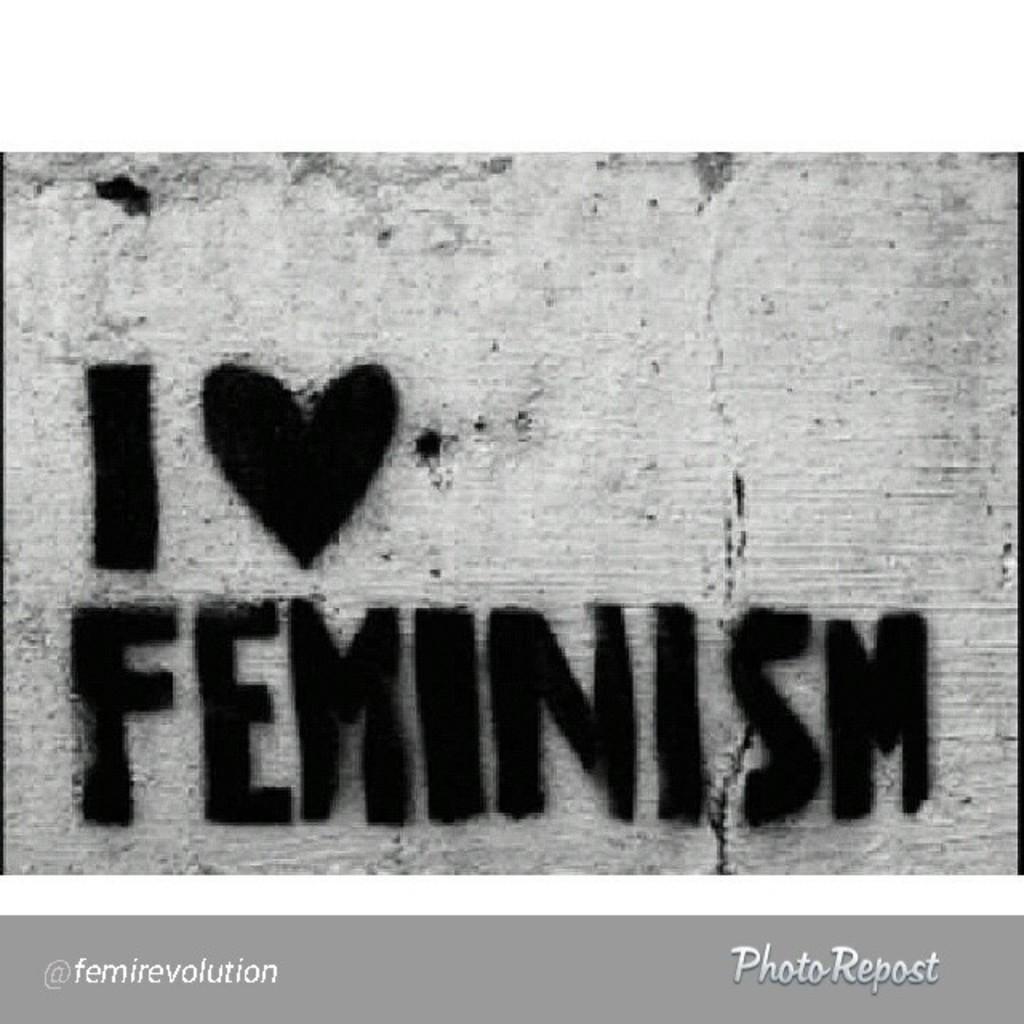You oppose or propose feminism?
Provide a succinct answer. Answering does not require reading text in the image. Who is tagged in this image?
Keep it short and to the point. Femirevolution. 